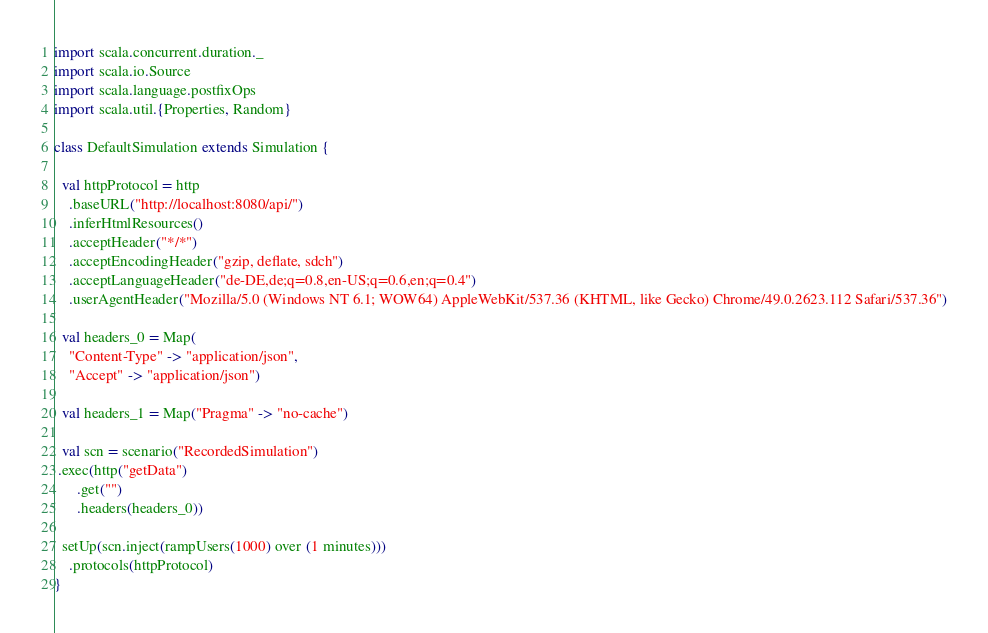<code> <loc_0><loc_0><loc_500><loc_500><_Scala_>import scala.concurrent.duration._
import scala.io.Source
import scala.language.postfixOps
import scala.util.{Properties, Random}

class DefaultSimulation extends Simulation {

  val httpProtocol = http
    .baseURL("http://localhost:8080/api/")
    .inferHtmlResources()
    .acceptHeader("*/*")
    .acceptEncodingHeader("gzip, deflate, sdch")
    .acceptLanguageHeader("de-DE,de;q=0.8,en-US;q=0.6,en;q=0.4")
    .userAgentHeader("Mozilla/5.0 (Windows NT 6.1; WOW64) AppleWebKit/537.36 (KHTML, like Gecko) Chrome/49.0.2623.112 Safari/537.36")

  val headers_0 = Map(
    "Content-Type" -> "application/json",
    "Accept" -> "application/json")

  val headers_1 = Map("Pragma" -> "no-cache")

  val scn = scenario("RecordedSimulation")
 .exec(http("getData")
      .get("")
      .headers(headers_0))

  setUp(scn.inject(rampUsers(1000) over (1 minutes)))
    .protocols(httpProtocol)
}</code> 